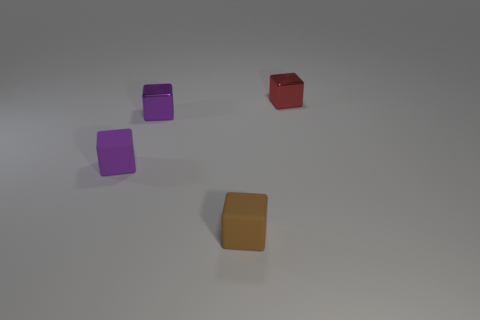Are there any small brown matte objects?
Make the answer very short. Yes. Does the small cube on the right side of the tiny brown matte cube have the same material as the brown cube?
Provide a short and direct response. No. How many brown rubber things are the same size as the brown cube?
Your response must be concise. 0. Are there an equal number of tiny matte objects that are on the right side of the tiny red block and small rubber blocks?
Ensure brevity in your answer.  No. How many cubes are to the right of the tiny purple metallic object and in front of the red metallic object?
Provide a short and direct response. 1. There is a purple cube that is the same material as the red object; what size is it?
Offer a very short reply. Small. What number of tiny purple things are the same shape as the red object?
Keep it short and to the point. 2. Is the number of matte cubes behind the small purple matte block greater than the number of things?
Offer a very short reply. No. There is a tiny object that is behind the purple rubber cube and in front of the red cube; what shape is it?
Offer a terse response. Cube. Is the size of the red object the same as the brown block?
Your response must be concise. Yes. 